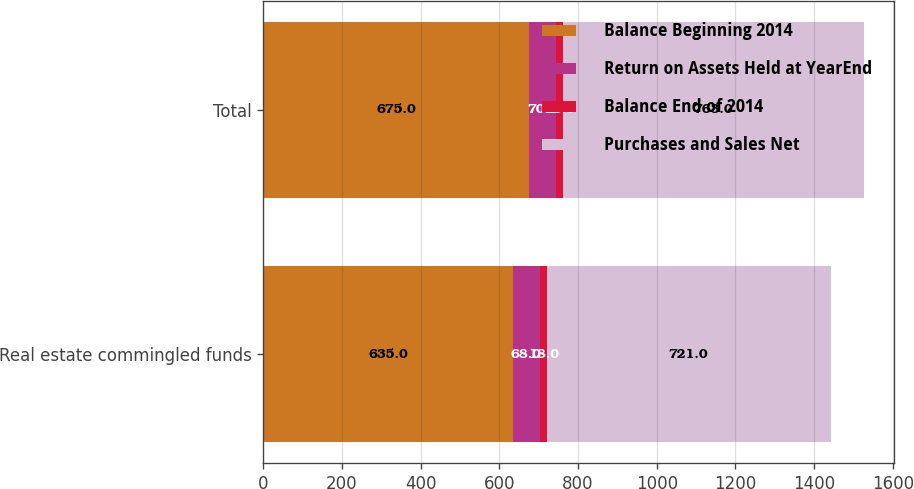Convert chart to OTSL. <chart><loc_0><loc_0><loc_500><loc_500><stacked_bar_chart><ecel><fcel>Real estate commingled funds<fcel>Total<nl><fcel>Balance Beginning 2014<fcel>635<fcel>675<nl><fcel>Return on Assets Held at YearEnd<fcel>68<fcel>70<nl><fcel>Balance End of 2014<fcel>18<fcel>18<nl><fcel>Purchases and Sales Net<fcel>721<fcel>763<nl></chart> 